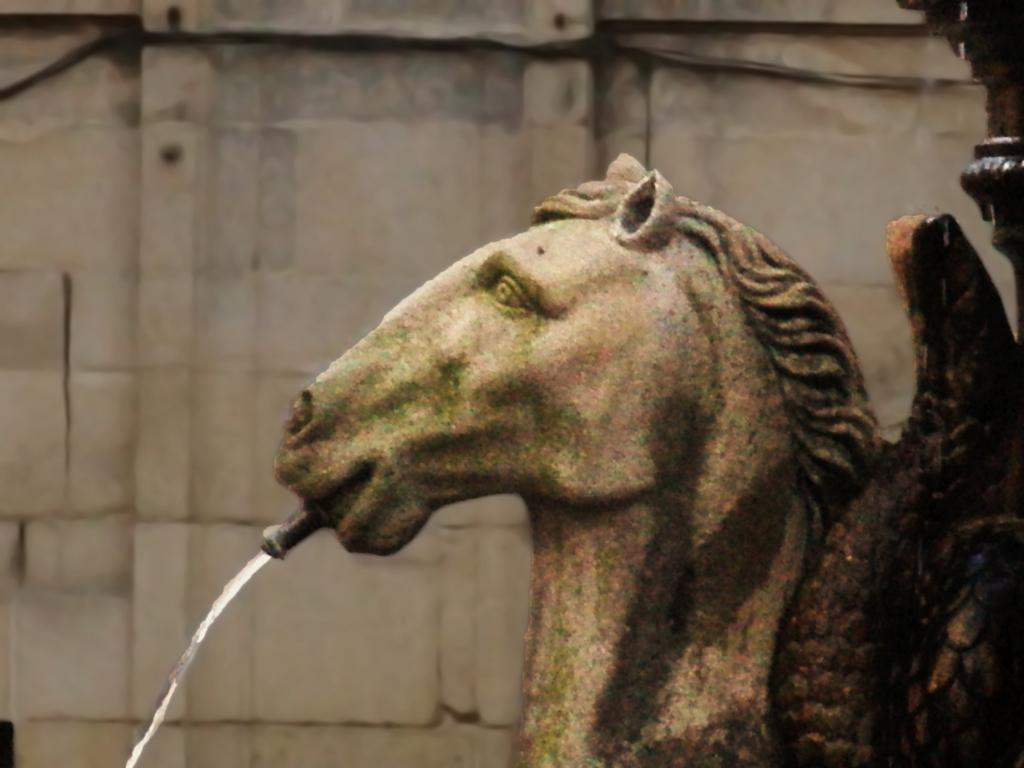What is located in the foreground of the image? There is a horse statue and a fountain in the foreground of the image. What can be seen in the background of the image? There is a building wall in the background of the image. Can you describe the lighting in the image? The image was likely taken during the day, as there is sufficient light. What type of thought can be seen in the bottle in the image? There is no bottle present in the image, and therefore no thoughts can be seen. What happens when the horse statue smashes the bottle in the image? There is no bottle in the image, and the horse statue is a statue, so it cannot smash anything. 